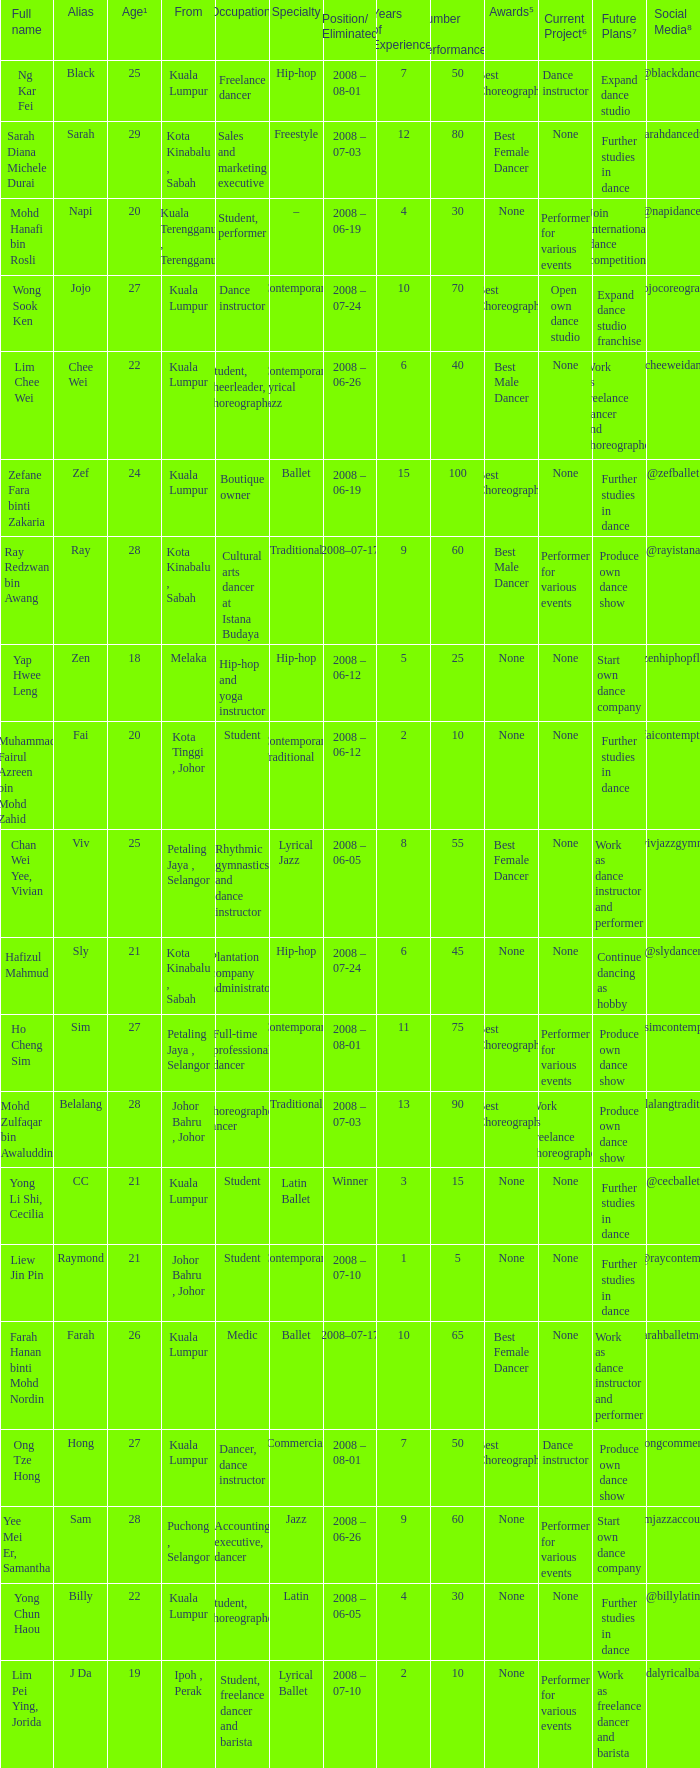Can you give me this table as a dict? {'header': ['Full name', 'Alias', 'Age¹', 'From', 'Occupation²', 'Specialty', 'Position/ Eliminated', 'Years of Experience³', 'Number of Performances⁴', 'Awards⁵', 'Current Project⁶', 'Future Plans⁷', 'Social Media⁸'], 'rows': [['Ng Kar Fei', 'Black', '25', 'Kuala Lumpur', 'Freelance dancer', 'Hip-hop', '2008 – 08-01', '7', '50', 'Best Choreography', 'Dance instructor', 'Expand dance studio', '@blackdance'], ['Sarah Diana Michele Durai', 'Sarah', '29', 'Kota Kinabalu , Sabah', 'Sales and marketing executive', 'Freestyle', '2008 – 07-03', '12', '80', 'Best Female Dancer', 'None', 'Further studies in dance', '@sarahdancedurai'], ['Mohd Hanafi bin Rosli', 'Napi', '20', 'Kuala Terengganu , Terengganu', 'Student, performer', '–', '2008 – 06-19', '4', '30', 'None', 'Performer for various events', 'Join international dance competition', '@napidancer'], ['Wong Sook Ken', 'Jojo', '27', 'Kuala Lumpur', 'Dance instructor', 'Contemporary', '2008 – 07-24', '10', '70', 'Best Choreography', 'Open own dance studio', 'Expand dance studio franchise', '@jojocoreography'], ['Lim Chee Wei', 'Chee Wei', '22', 'Kuala Lumpur', 'Student, cheerleader, choreographer', 'Contemporary Lyrical Jazz', '2008 – 06-26', '6', '40', 'Best Male Dancer', 'None', 'Work as freelance dancer and choreographer', '@cheeweidance'], ['Zefane Fara binti Zakaria', 'Zef', '24', 'Kuala Lumpur', 'Boutique owner', 'Ballet', '2008 – 06-19', '15', '100', 'Best Choreography', 'None', 'Further studies in dance', '@zefballet'], ['Ray Redzwan bin Awang', 'Ray', '28', 'Kota Kinabalu , Sabah', 'Cultural arts dancer at Istana Budaya', 'Traditional', '2008–07-17', '9', '60', 'Best Male Dancer', 'Performer for various events', 'Produce own dance show', '@rayistana'], ['Yap Hwee Leng', 'Zen', '18', 'Melaka', 'Hip-hop and yoga instructor', 'Hip-hop', '2008 – 06-12', '5', '25', 'None', 'None', 'Start own dance company', '@zenhiphopflow'], ['Muhammad Fairul Azreen bin Mohd Zahid', 'Fai', '20', 'Kota Tinggi , Johor', 'Student', 'Contemporary Traditional', '2008 – 06-12', '2', '10', 'None', 'None', 'Further studies in dance', '@faicontemptrad'], ['Chan Wei Yee, Vivian', 'Viv', '25', 'Petaling Jaya , Selangor', 'Rhythmic gymnastics and dance instructor', 'Lyrical Jazz', '2008 – 06-05', '8', '55', 'Best Female Dancer', 'None', 'Work as dance instructor and performer', '@vivjazzgymnast'], ['Hafizul Mahmud', 'Sly', '21', 'Kota Kinabalu , Sabah', 'Plantation company administrator', 'Hip-hop', '2008 – 07-24', '6', '45', 'None', 'None', 'Continue dancing as hobby', '@slydancer'], ['Ho Cheng Sim', 'Sim', '27', 'Petaling Jaya , Selangor', 'Full-time professional dancer', 'Contemporary', '2008 – 08-01', '11', '75', 'Best Choreography', 'Performer for various events', 'Produce own dance show', '@simcontempro'], ['Mohd Zulfaqar bin Awaluddin', 'Belalang', '28', 'Johor Bahru , Johor', 'Choreographer, dancer', 'Traditional', '2008 – 07-03', '13', '90', 'Best Choreography', 'Work as freelance choreographer', 'Produce own dance show', '@belalangtraditional'], ['Yong Li Shi, Cecilia', 'CC', '21', 'Kuala Lumpur', 'Student', 'Latin Ballet', 'Winner', '3', '15', 'None', 'None', 'Further studies in dance', '@cecballet'], ['Liew Jin Pin', 'Raymond', '21', 'Johor Bahru , Johor', 'Student', 'Contemporary', '2008 – 07-10', '1', '5', 'None', 'None', 'Further studies in dance', '@raycontemp'], ['Farah Hanan binti Mohd Nordin', 'Farah', '26', 'Kuala Lumpur', 'Medic', 'Ballet', '2008–07-17', '10', '65', 'Best Female Dancer', 'None', 'Work as dance instructor and performer', '@farahballetmedic'], ['Ong Tze Hong', 'Hong', '27', 'Kuala Lumpur', 'Dancer, dance instructor', 'Commercial', '2008 – 08-01', '7', '50', 'Best Choreography', 'Dance instructor', 'Produce own dance show', '@hongcommercial'], ['Yee Mei Er, Samantha', 'Sam', '28', 'Puchong , Selangor', 'Accounting executive, dancer', 'Jazz', '2008 – 06-26', '9', '60', 'None', 'Performer for various events', 'Start own dance company', '@samjazzaccountant'], ['Yong Chun Haou', 'Billy', '22', 'Kuala Lumpur', 'Student, choreographer', 'Latin', '2008 – 06-05', '4', '30', 'None', 'None', 'Further studies in dance', '@billylatin'], ['Lim Pei Ying, Jorida', 'J Da', '19', 'Ipoh , Perak', 'Student, freelance dancer and barista', 'Lyrical Ballet', '2008 – 07-10', '2', '10', 'None', 'Performer for various events', 'Work as freelance dancer and barista', '@jdalyricalballet']]} What is Full Name, when Age¹ is "20", and when Occupation² is "Student"? Muhammad Fairul Azreen bin Mohd Zahid. 